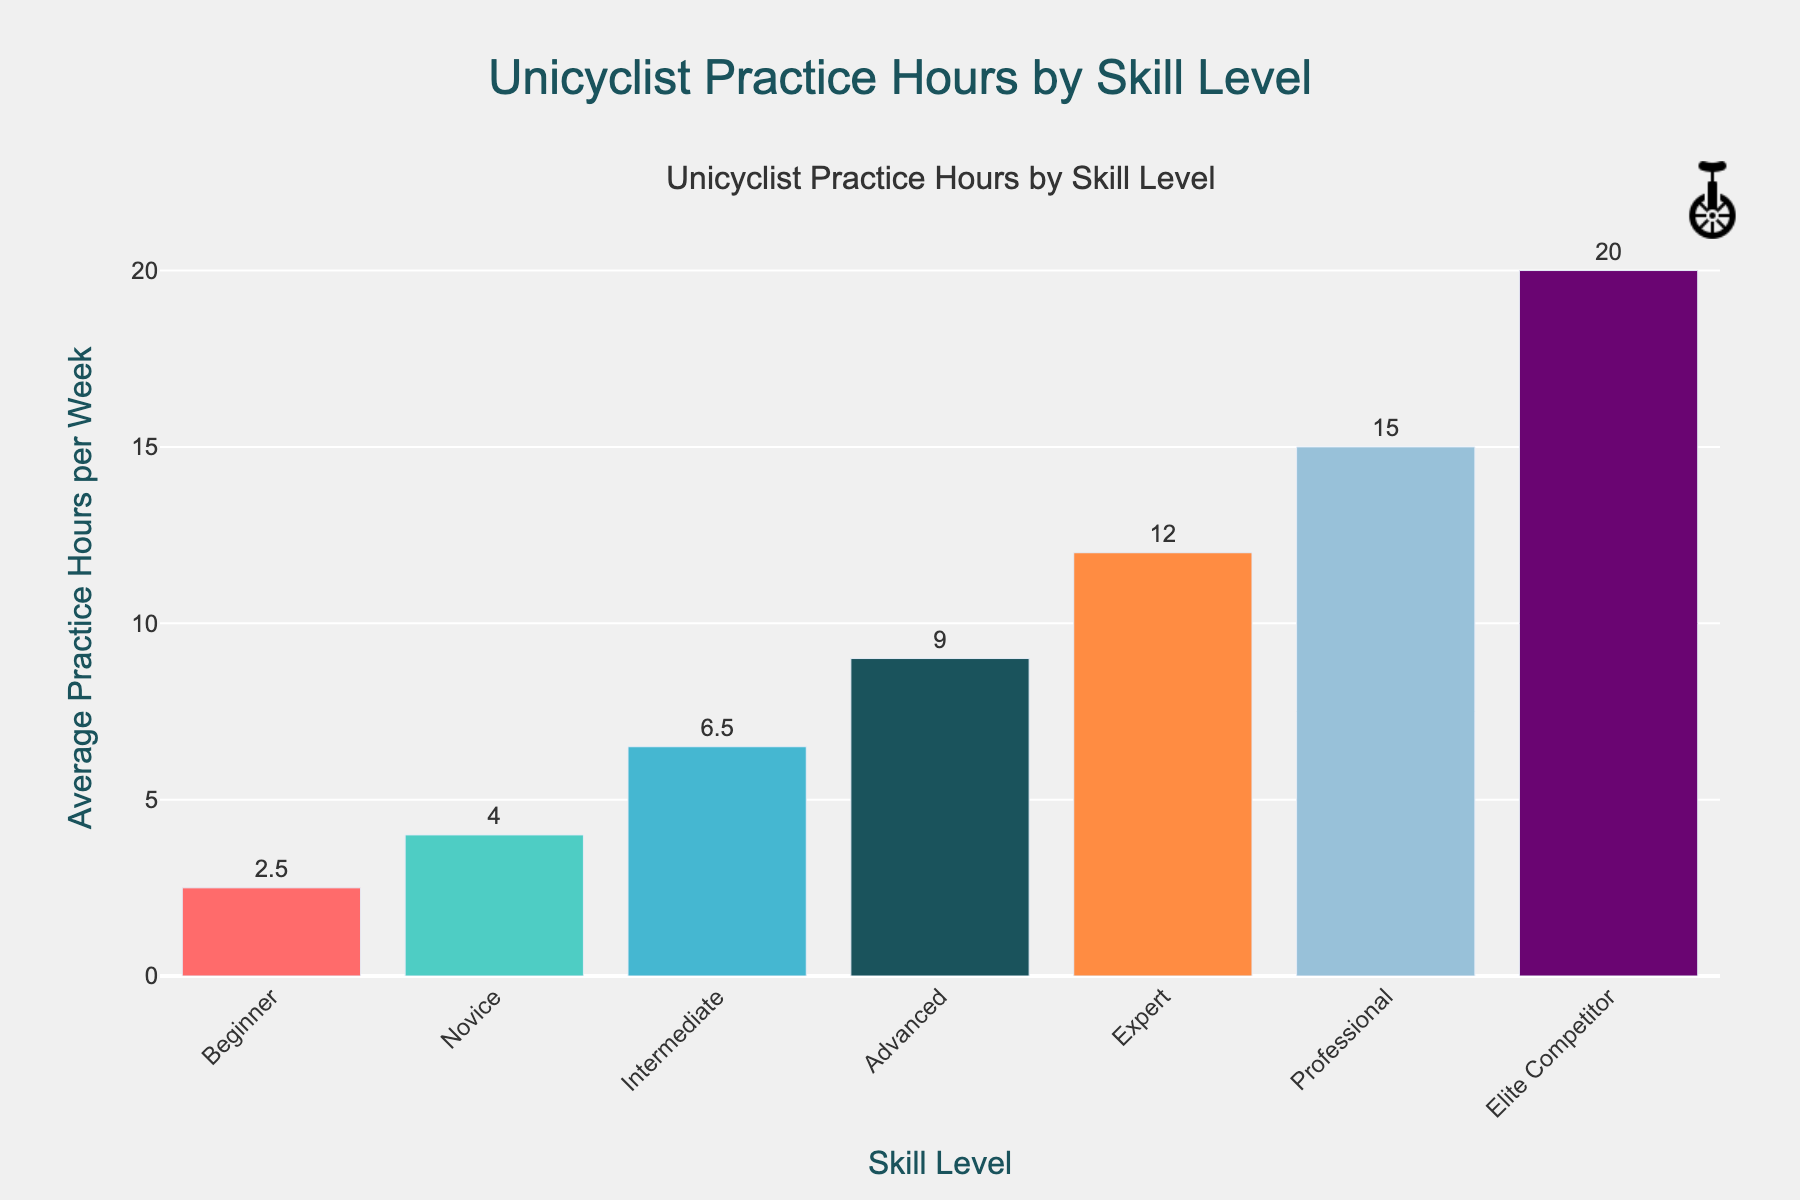What's the difference in average practice hours per week between Elite Competitor and Intermediate skill levels? To find the difference, subtract the average practice hours of the Intermediate level (6.5) from the Elite Competitor level (20). 20 - 6.5 = 13.5.
Answer: 13.5 Which skill level practices the least per week? The skill level with the smallest bar represents the minimum average practice hours. The Beginner skill level has the smallest bar with 2.5 hours.
Answer: Beginner What's the combined average practice hours per week for Novice and Professional skill levels? Add the average practice hours of the Novice level (4) and the Professional level (15). 4 + 15 = 19.
Answer: 19 How many more hours does an Expert practice compared to a Novice per week? Subtract the average practice hours of the Novice level (4) from the Expert level (12). 12 - 4 = 8.
Answer: 8 What’s the average of the practice hours per week for the Beginner, Intermediate, and Advanced skill levels? Add the average practice hours of the Beginner (2.5), Intermediate (6.5), and Advanced (9) levels, and then divide by 3. (2.5 + 6.5 + 9) / 3 = 6.
Answer: 6 Which skill level has the second highest average practice hours per week? The second tallest bar corresponds to the Professional skill level with 15 average practice hours per week, while the tallest bar corresponds to the Elite Competitor skill level.
Answer: Professional Does the average practice hours per week increase consistently with skill level? Reviewing the heights of the bars from Beginner to Elite Competitor, each subsequent bar is taller than the previous one, indicating a consistent increase in practice hours with skill level.
Answer: Yes If the total practice hours for all skill levels are combined, what is the sum? Add the average practice hours for each skill level: 2.5 + 4 + 6.5 + 9 + 12 + 15 + 20 = 69.
Answer: 69 What is the range of average practice hours per week across all skill levels? Subtract the smallest average practice hours (Beginner: 2.5) from the largest (Elite Competitor: 20). 20 - 2.5 = 17.5.
Answer: 17.5 How does the average practice hours of the Advanced skill level compare to that of the Intermediate skill level? The bar height of Advanced (9) is greater than Intermediate (6.5). Subtracting, 9 - 6.5 gives 2.5, so the Advanced skill level practices 2.5 more hours on average per week than the Intermediate level.
Answer: 2.5 more hours 